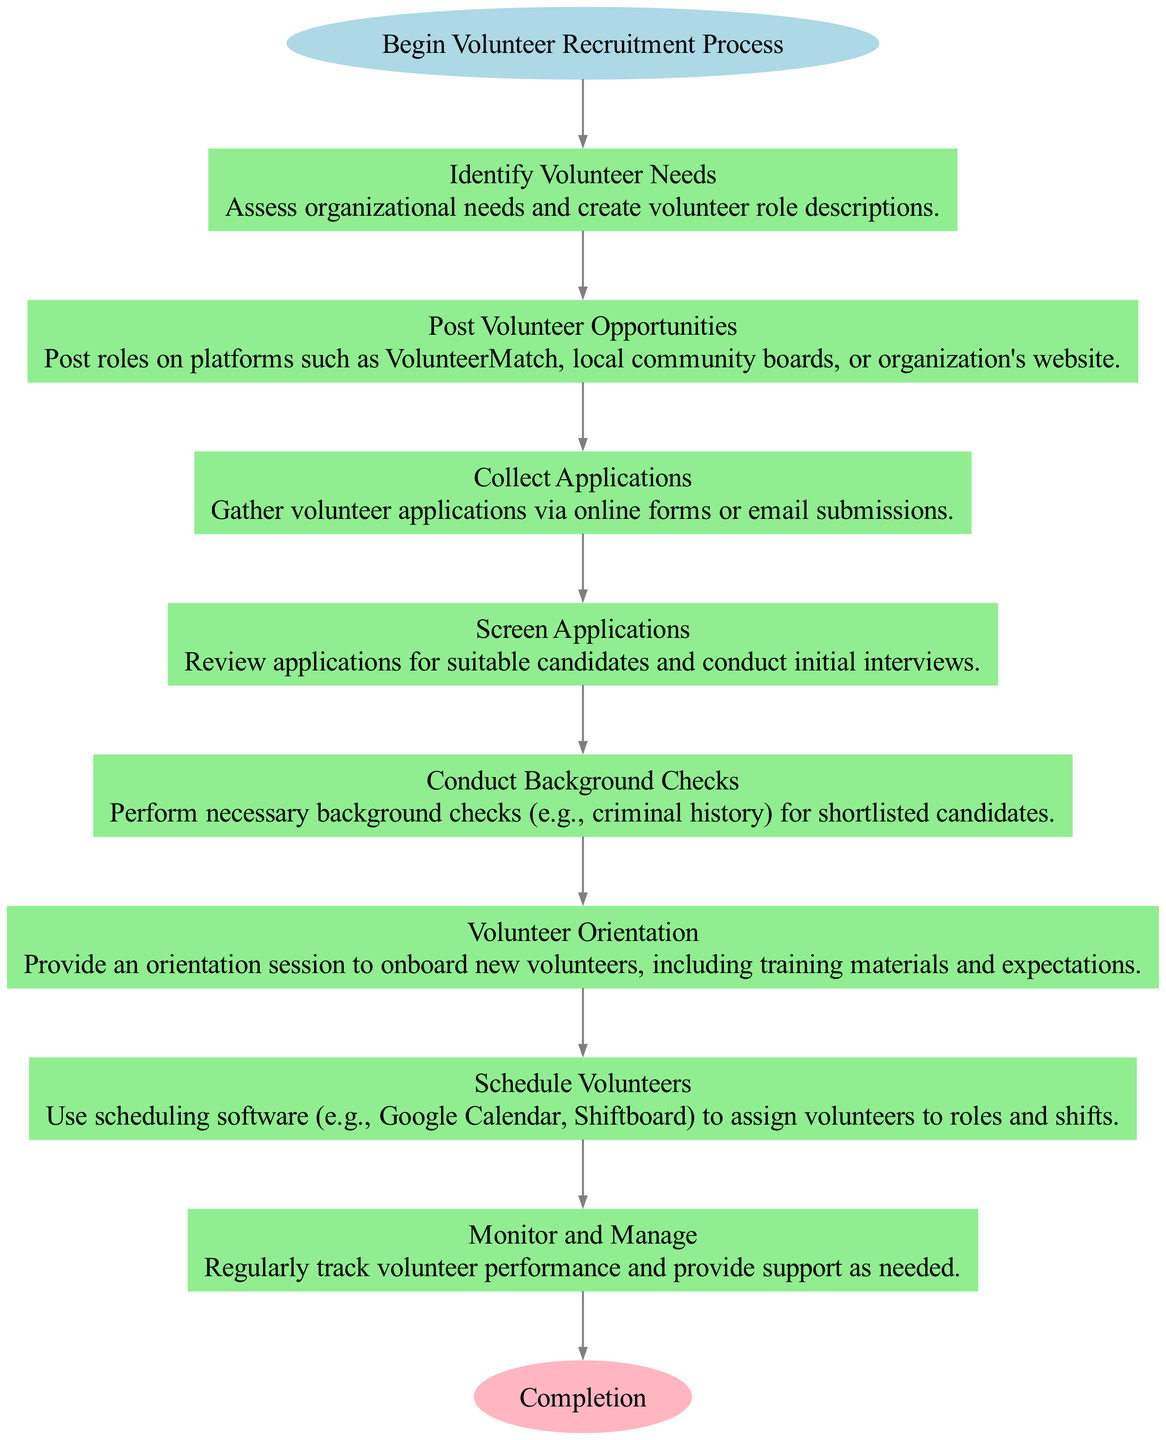What is the first step in the Volunteer Recruitment Process? The diagram starts with the node labeled "Begin Volunteer Recruitment Process", which is connected to the first step. This first step is identified as "Identify Volunteer Needs."
Answer: Identify Volunteer Needs How many total steps are there from start to end? In the diagram, there are 8 steps listed, including the start and end nodes. Therefore, including the start and end nodes, there are 8 total nodes present in the flow chart.
Answer: 8 What is the last step before completion? The last step is labeled "Monitor and Manage." The last node before reaching the end node is always the last action before completion in a flow chart.
Answer: Monitor and Manage What action occurs after conducting background checks? After "Conduct Background Checks," the next step indicated in the flow chart is "Volunteer Orientation." This follows the logical flow from screening candidates to onboarding them.
Answer: Volunteer Orientation How many edges are there connecting the steps? The flow chart shows a direct connection (edge) between each step leading up to the completion node. Since there are 7 steps with edges connecting them, this results in 7 edges present in the diagram.
Answer: 7 Which step involves posting opportunities? The step labeled "Post Volunteer Opportunities" specifies the action of posting volunteer roles to various platforms. This is indicated clearly as the second step in the process.
Answer: Post Volunteer Opportunities What is the focus of the first step? The first step "Identify Volunteer Needs" focuses on assessing the organizational needs and creating volunteer role descriptions, as described in the flow chart.
Answer: Assess organizational needs What is the purpose of monitoring and managing volunteers? The step "Monitor and Manage" is aimed at regularly tracking volunteer performance and providing necessary support. This is crucial for maintaining efficient operations and ensuring volunteer satisfaction.
Answer: Track performance and provide support 